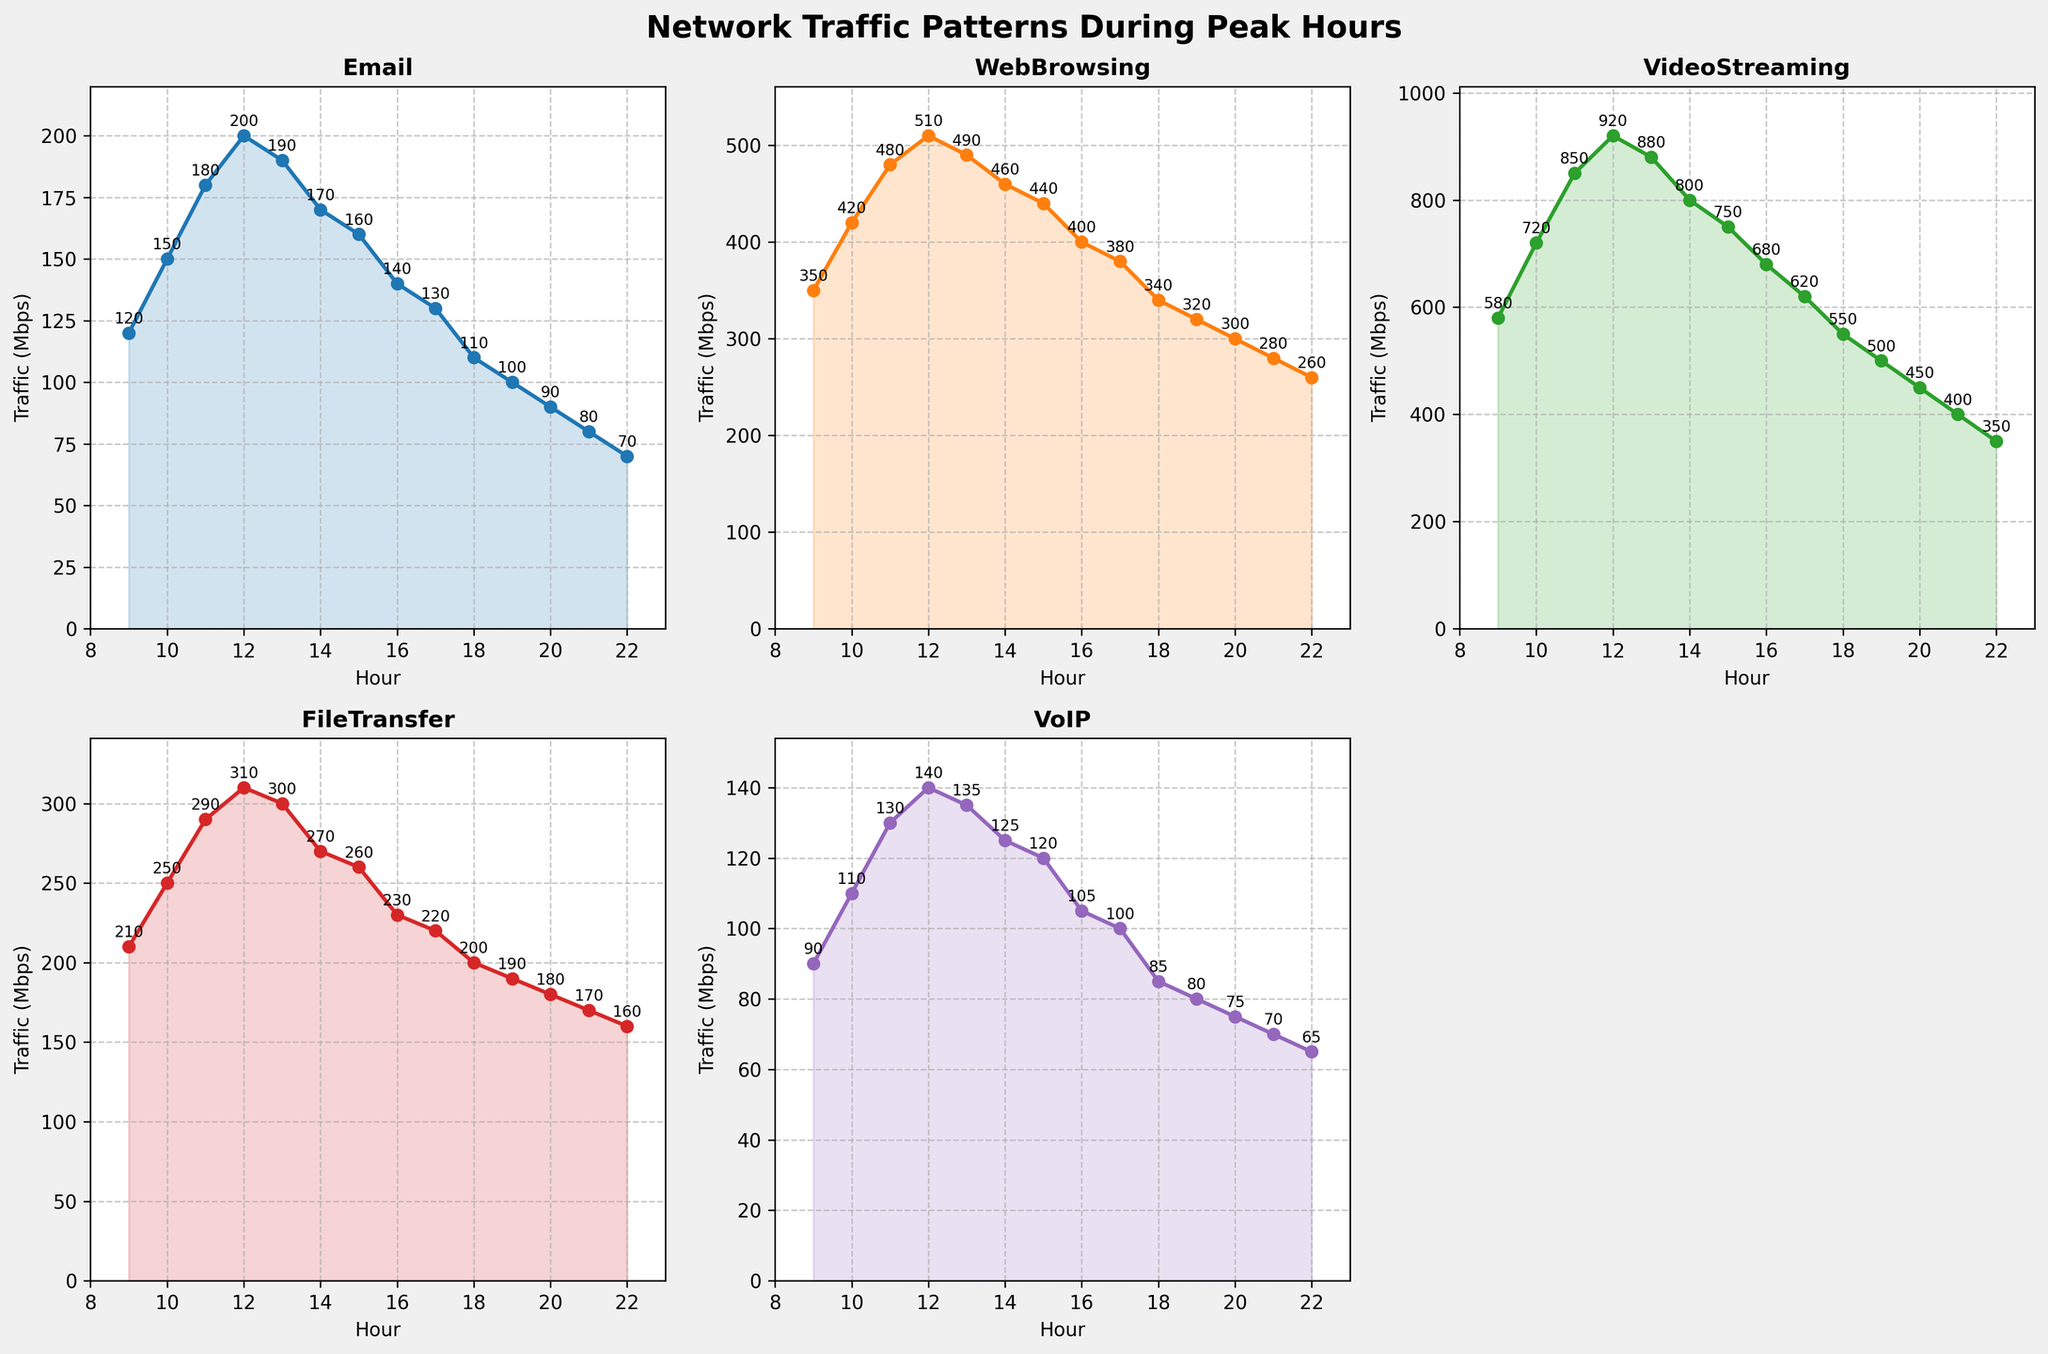What is the peak traffic hour for Email and what is the traffic at that time? To find the peak traffic hour for Email, look for the highest point in the Email subplot. The highest value for Email occurs at hour 12 with a traffic of 200 Mbps.
Answer: 12, 200 Mbps Compare the traffic for WebBrowsing and VoIP at 10 AM. Which one has higher traffic and by how much? Checking the values at 10 AM, WebBrowsing has 420 Mbps, and VoIP has 110 Mbps. WebBrowsing has higher traffic by (420 - 110) = 310 Mbps.
Answer: WebBrowsing, 310 Mbps At which hour does VideoStreaming have its peak traffic, and what is the corresponding value? For VideoStreaming, find the highest peak in its subplot. The peak occurs at 12 PM with a traffic of 920 Mbps.
Answer: 12, 920 Mbps What is the average traffic for FileTransfer between 12 PM and 18 PM? Sum the traffic values for FileTransfer from hours 12 to 18: (310 + 300 + 270 + 260 + 230 + 220 + 200) = 1790 Mbps. The number of data points is 7. So the average is 1790 / 7 = 255.71 Mbps.
Answer: 255.71 Mbps Which application has the lowest traffic at 9 AM, and what is the value? At 9 AM, VoIP has the lowest traffic at 90 Mbps.
Answer: VoIP, 90 Mbps Is the traffic for VideoStreaming ever lower than the peak traffic for WebBrowsing (510 Mbps)? Check the values for VideoStreaming and compare them to the peak of WebBrowsing (510 Mbps). Only the value at 22 PM (350 Mbps) is lower than 510 Mbps.
Answer: Yes How does the traffic for FileTransfer change between 10 AM and 15 PM? For FileTransfer, compare the values: 10 AM (250 Mbps), 11 AM (290 Mbps), 12 PM (310 Mbps), 13 PM (300 Mbps), 14 PM (270 Mbps), and 15 PM (260 Mbps). Notice the trend: it increases to 12 PM, then starts decreasing.
Answer: Increases then decreases Calculate the sum of traffic for VoIP at 9 AM, 12 PM, and 3 PM. Sum the values for VoIP at 9 AM (90 Mbps), 12 PM (140 Mbps), and 3 PM (120 Mbps): 90 + 140 + 120 = 350 Mbps.
Answer: 350 Mbps 